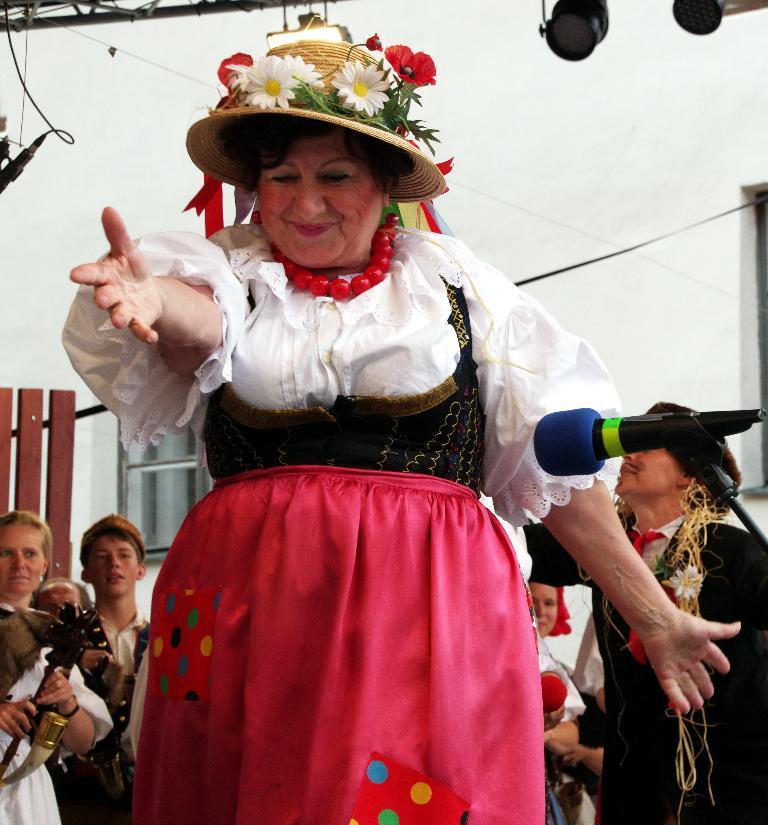Describe this image in one or two sentences. In this image there is a person in a fancy dress is standing and smiling, there is a mike with a mike stand, and in the background there are group of people in fancy dresses are standing , focus lights, lighting truss, building. 